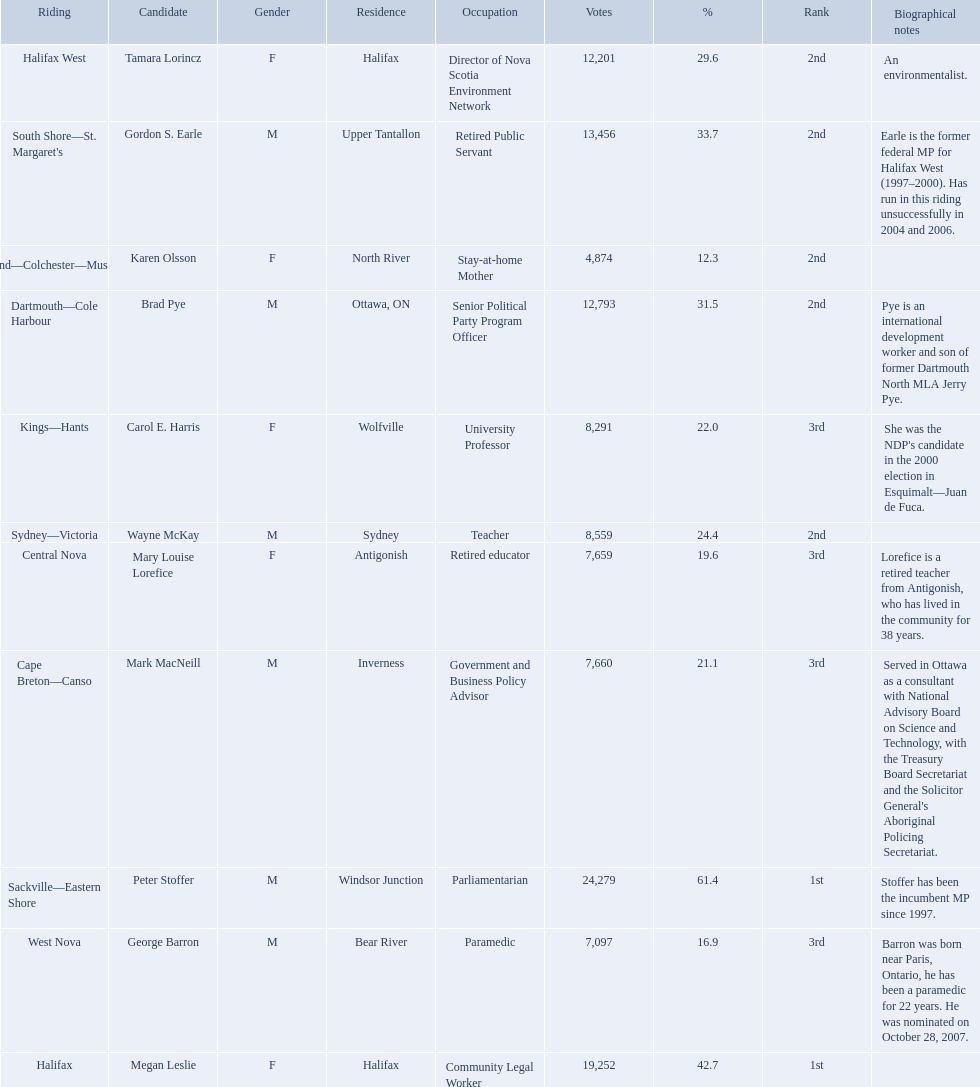What new democratic party candidates ran in the 2008 canadian federal election? Mark MacNeill, Mary Louise Lorefice, Karen Olsson, Brad Pye, Megan Leslie, Tamara Lorincz, Carol E. Harris, Peter Stoffer, Gordon S. Earle, Wayne McKay, George Barron. Of these candidates, which are female? Mary Louise Lorefice, Karen Olsson, Megan Leslie, Tamara Lorincz, Carol E. Harris. Which of these candidates resides in halifax? Megan Leslie, Tamara Lorincz. Of the remaining two, which was ranked 1st? Megan Leslie. How many votes did she get? 19,252. 